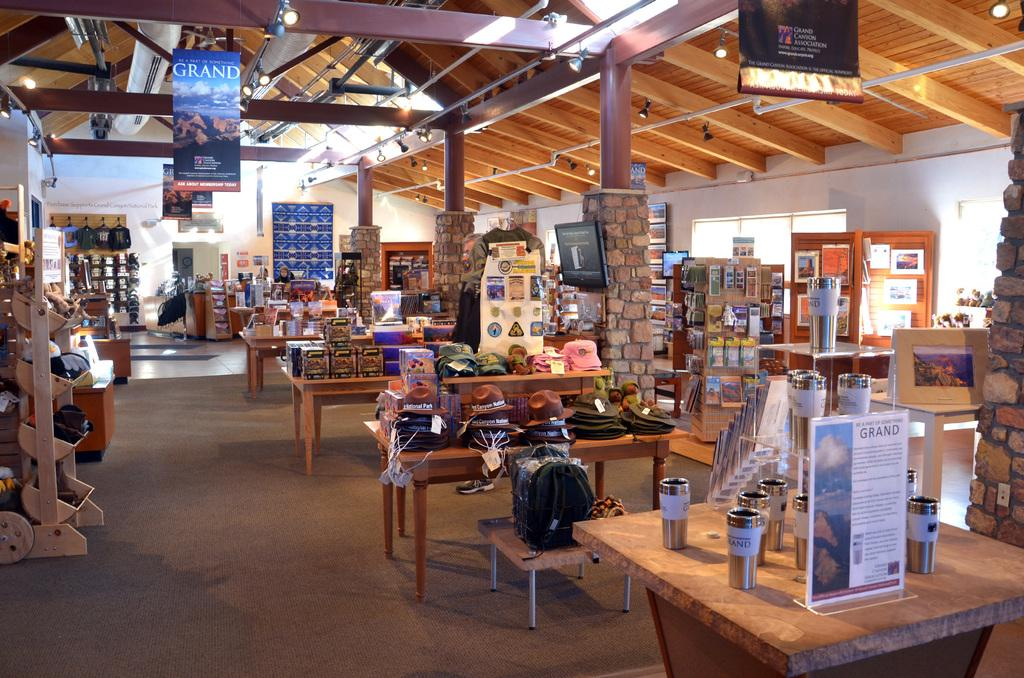What objects can be seen on the tables in the image? There are glasses, bags, caps, and books on the tables in the image. What else can be found in the room besides the tables? There are objects on the racks, windows, poles, and lights in the image. What is the color of the background wall in the image? The background wall is white. How many babies are present in the image? There are no babies present in the image. What is the tendency of the division between the objects on the tables and the objects on the racks? There is no division mentioned or visible in the image, and therefore no tendency can be determined. 